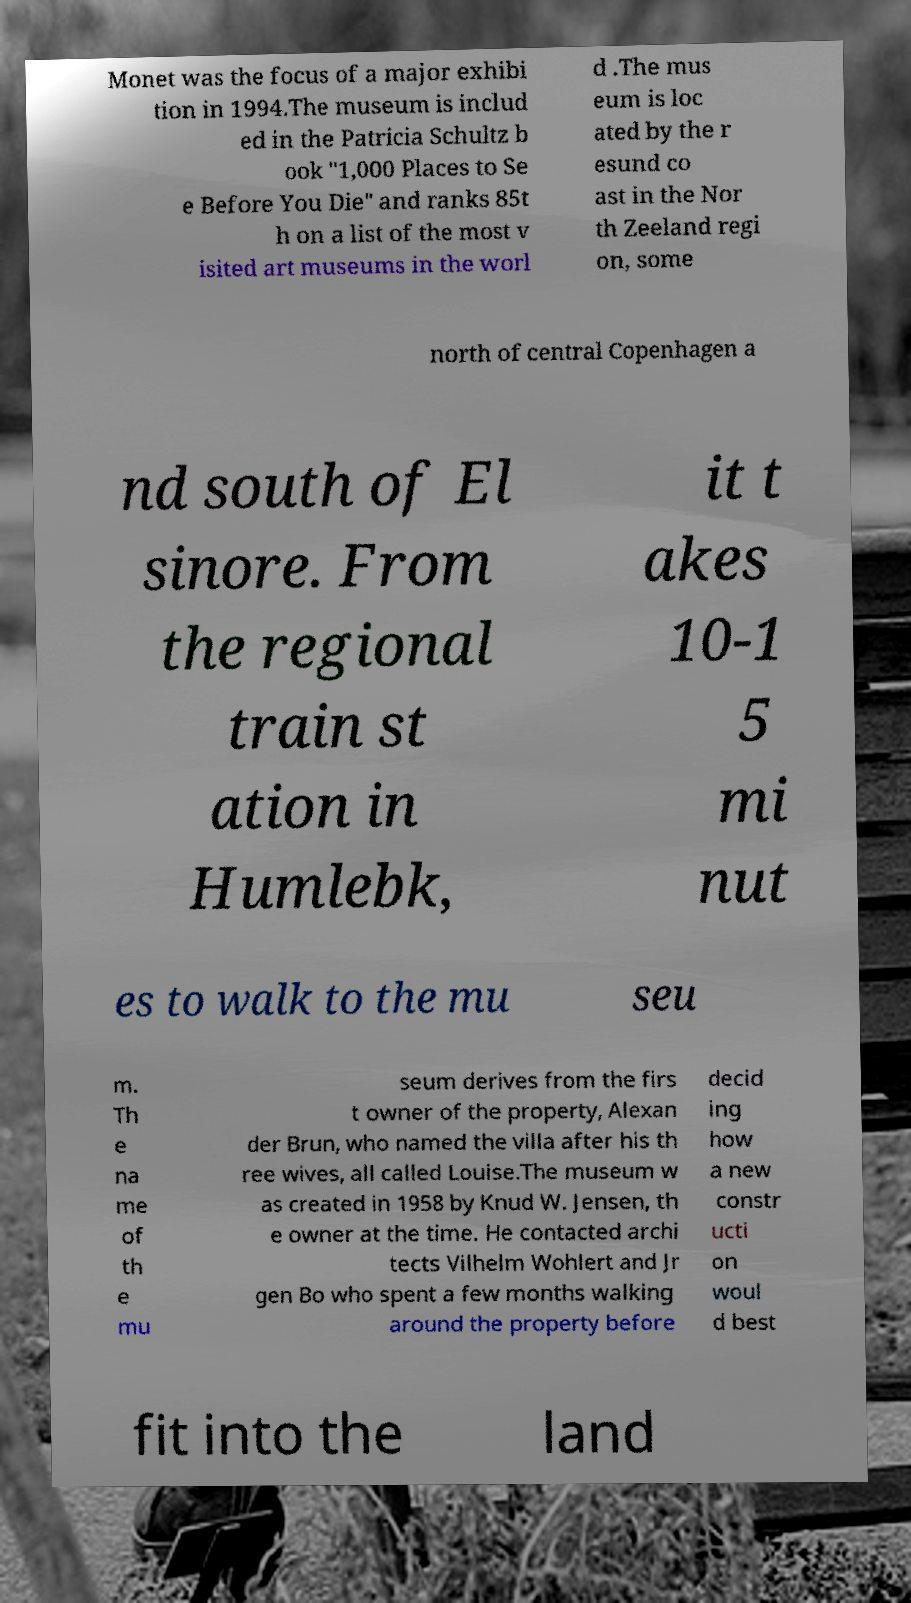Please read and relay the text visible in this image. What does it say? Monet was the focus of a major exhibi tion in 1994.The museum is includ ed in the Patricia Schultz b ook "1,000 Places to Se e Before You Die" and ranks 85t h on a list of the most v isited art museums in the worl d .The mus eum is loc ated by the r esund co ast in the Nor th Zeeland regi on, some north of central Copenhagen a nd south of El sinore. From the regional train st ation in Humlebk, it t akes 10-1 5 mi nut es to walk to the mu seu m. Th e na me of th e mu seum derives from the firs t owner of the property, Alexan der Brun, who named the villa after his th ree wives, all called Louise.The museum w as created in 1958 by Knud W. Jensen, th e owner at the time. He contacted archi tects Vilhelm Wohlert and Jr gen Bo who spent a few months walking around the property before decid ing how a new constr ucti on woul d best fit into the land 